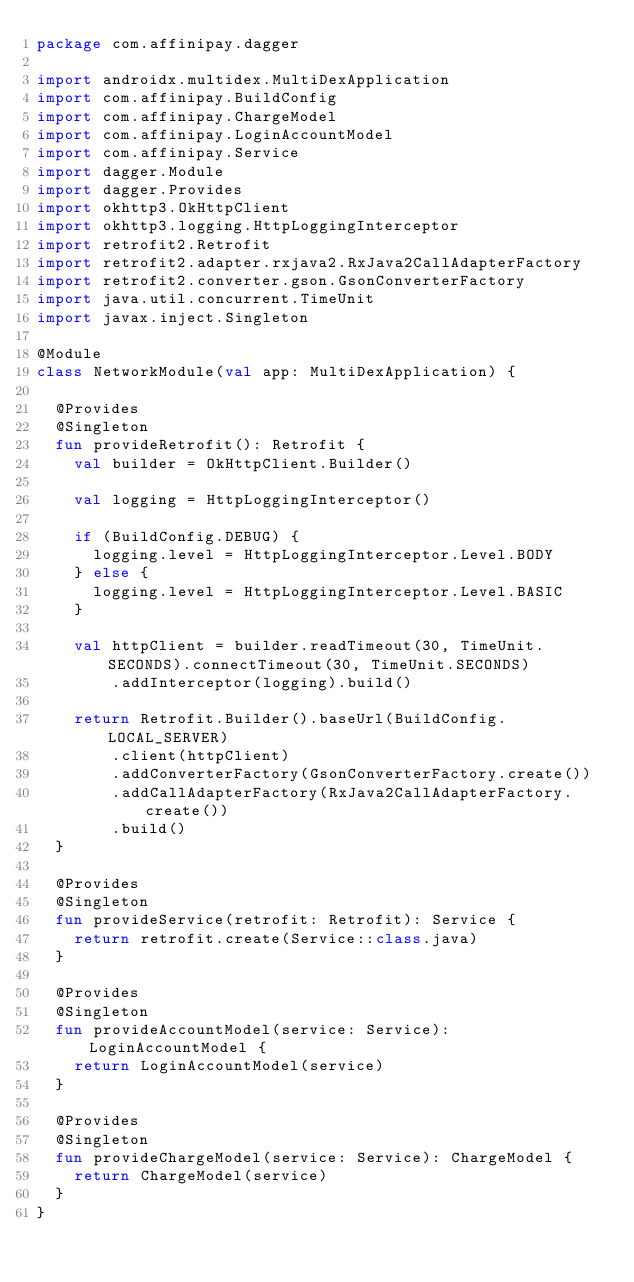<code> <loc_0><loc_0><loc_500><loc_500><_Kotlin_>package com.affinipay.dagger

import androidx.multidex.MultiDexApplication
import com.affinipay.BuildConfig
import com.affinipay.ChargeModel
import com.affinipay.LoginAccountModel
import com.affinipay.Service
import dagger.Module
import dagger.Provides
import okhttp3.OkHttpClient
import okhttp3.logging.HttpLoggingInterceptor
import retrofit2.Retrofit
import retrofit2.adapter.rxjava2.RxJava2CallAdapterFactory
import retrofit2.converter.gson.GsonConverterFactory
import java.util.concurrent.TimeUnit
import javax.inject.Singleton

@Module
class NetworkModule(val app: MultiDexApplication) {

  @Provides
  @Singleton
  fun provideRetrofit(): Retrofit {
    val builder = OkHttpClient.Builder()

    val logging = HttpLoggingInterceptor()

    if (BuildConfig.DEBUG) {
      logging.level = HttpLoggingInterceptor.Level.BODY
    } else {
      logging.level = HttpLoggingInterceptor.Level.BASIC
    }

    val httpClient = builder.readTimeout(30, TimeUnit.SECONDS).connectTimeout(30, TimeUnit.SECONDS)
        .addInterceptor(logging).build()

    return Retrofit.Builder().baseUrl(BuildConfig.LOCAL_SERVER)
        .client(httpClient)
        .addConverterFactory(GsonConverterFactory.create())
        .addCallAdapterFactory(RxJava2CallAdapterFactory.create())
        .build()
  }

  @Provides
  @Singleton
  fun provideService(retrofit: Retrofit): Service {
    return retrofit.create(Service::class.java)
  }

  @Provides
  @Singleton
  fun provideAccountModel(service: Service): LoginAccountModel {
    return LoginAccountModel(service)
  }

  @Provides
  @Singleton
  fun provideChargeModel(service: Service): ChargeModel {
    return ChargeModel(service)
  }
}
</code> 